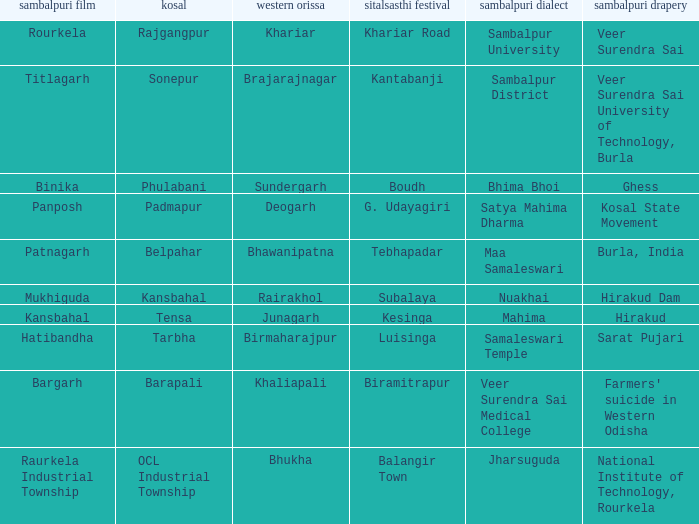What is the sitalsasthi carnival with hirakud as sambalpuri saree? Kesinga. 